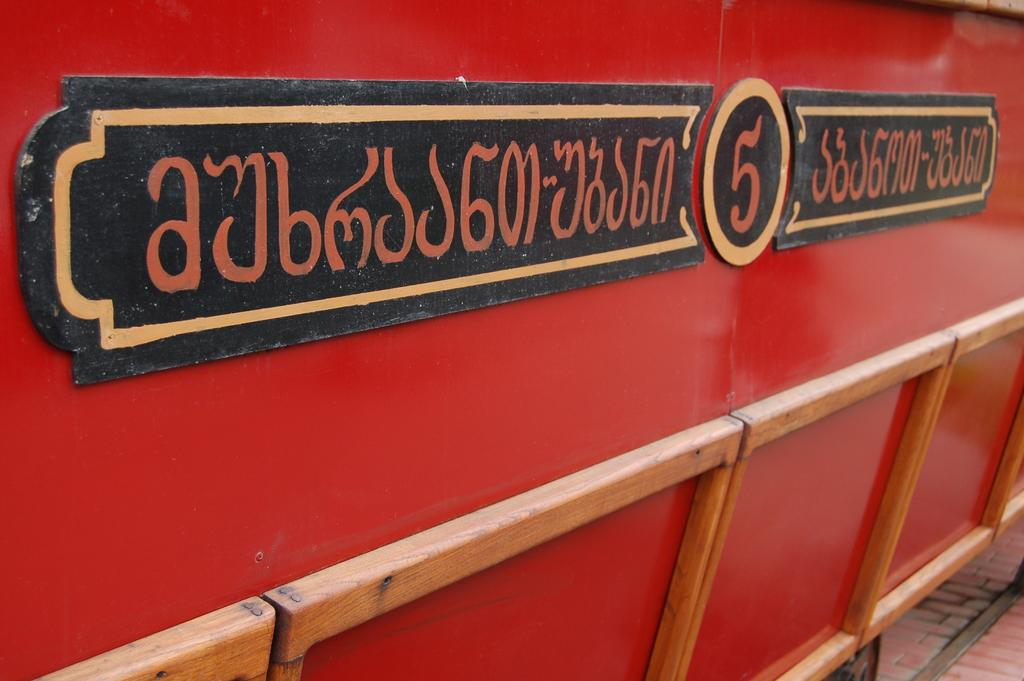What color is the object on the floor in the image? The object on the floor is red. What is written on the board in the image? There is text written on a board in the image. How is the board connected to the red object? The board is attached to the red object. What type of cub can be seen playing with a sweater in the image? There is no cub or sweater present in the image. What color is the paint on the red object in the image? There is no paint visible on the red object in the image; it is simply red. 